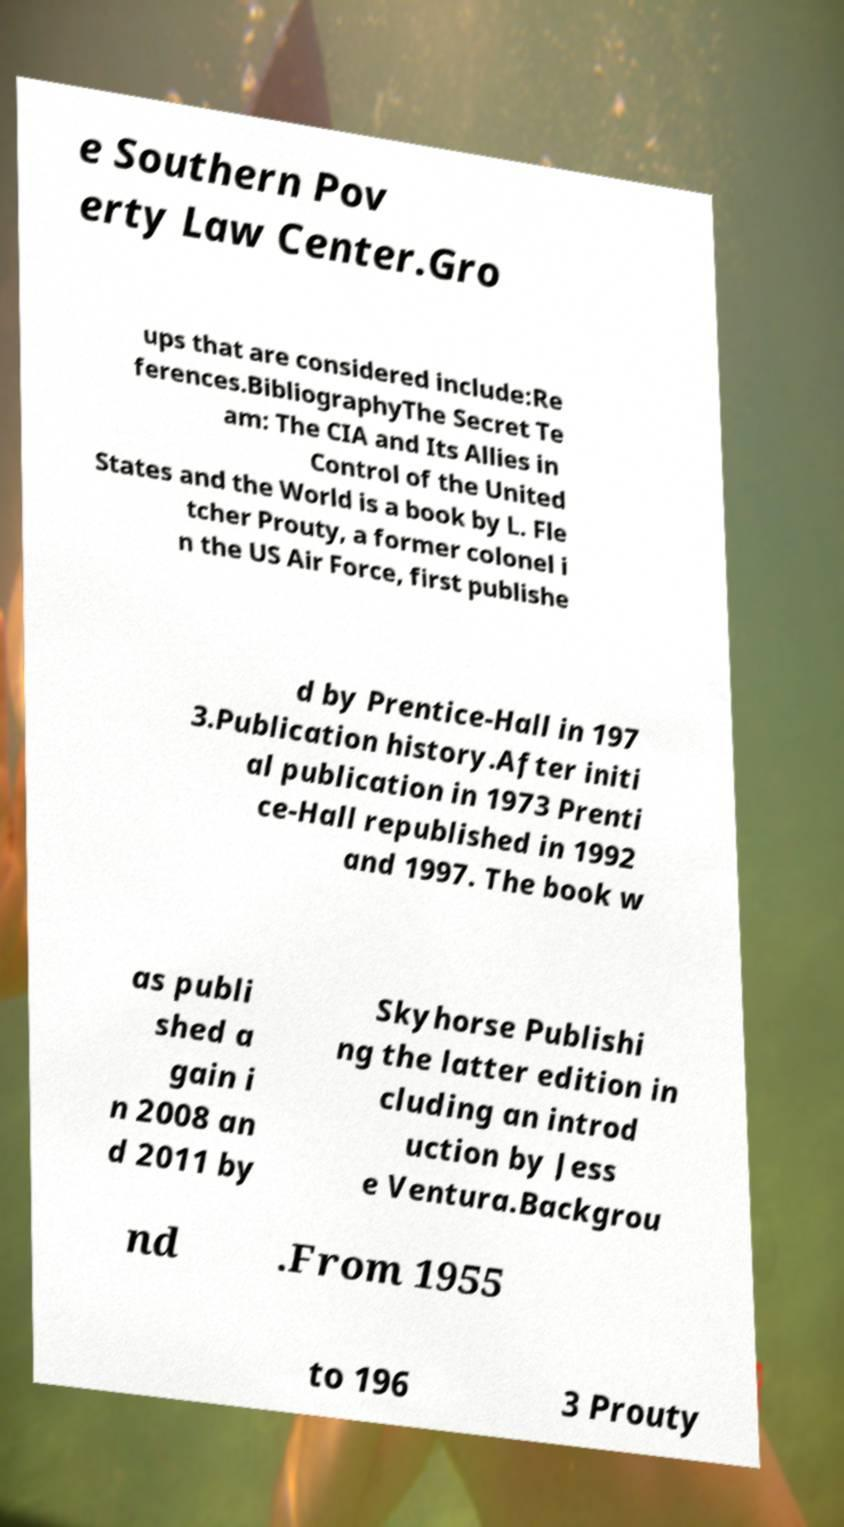I need the written content from this picture converted into text. Can you do that? e Southern Pov erty Law Center.Gro ups that are considered include:Re ferences.BibliographyThe Secret Te am: The CIA and Its Allies in Control of the United States and the World is a book by L. Fle tcher Prouty, a former colonel i n the US Air Force, first publishe d by Prentice-Hall in 197 3.Publication history.After initi al publication in 1973 Prenti ce-Hall republished in 1992 and 1997. The book w as publi shed a gain i n 2008 an d 2011 by Skyhorse Publishi ng the latter edition in cluding an introd uction by Jess e Ventura.Backgrou nd .From 1955 to 196 3 Prouty 